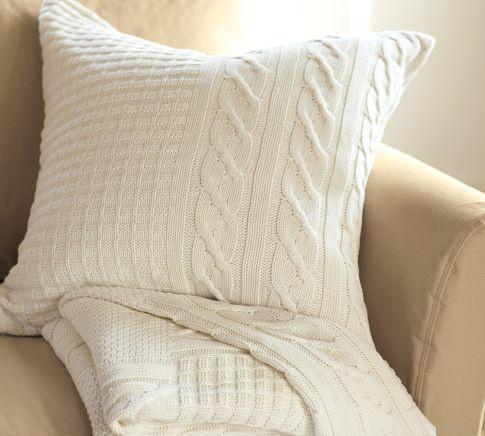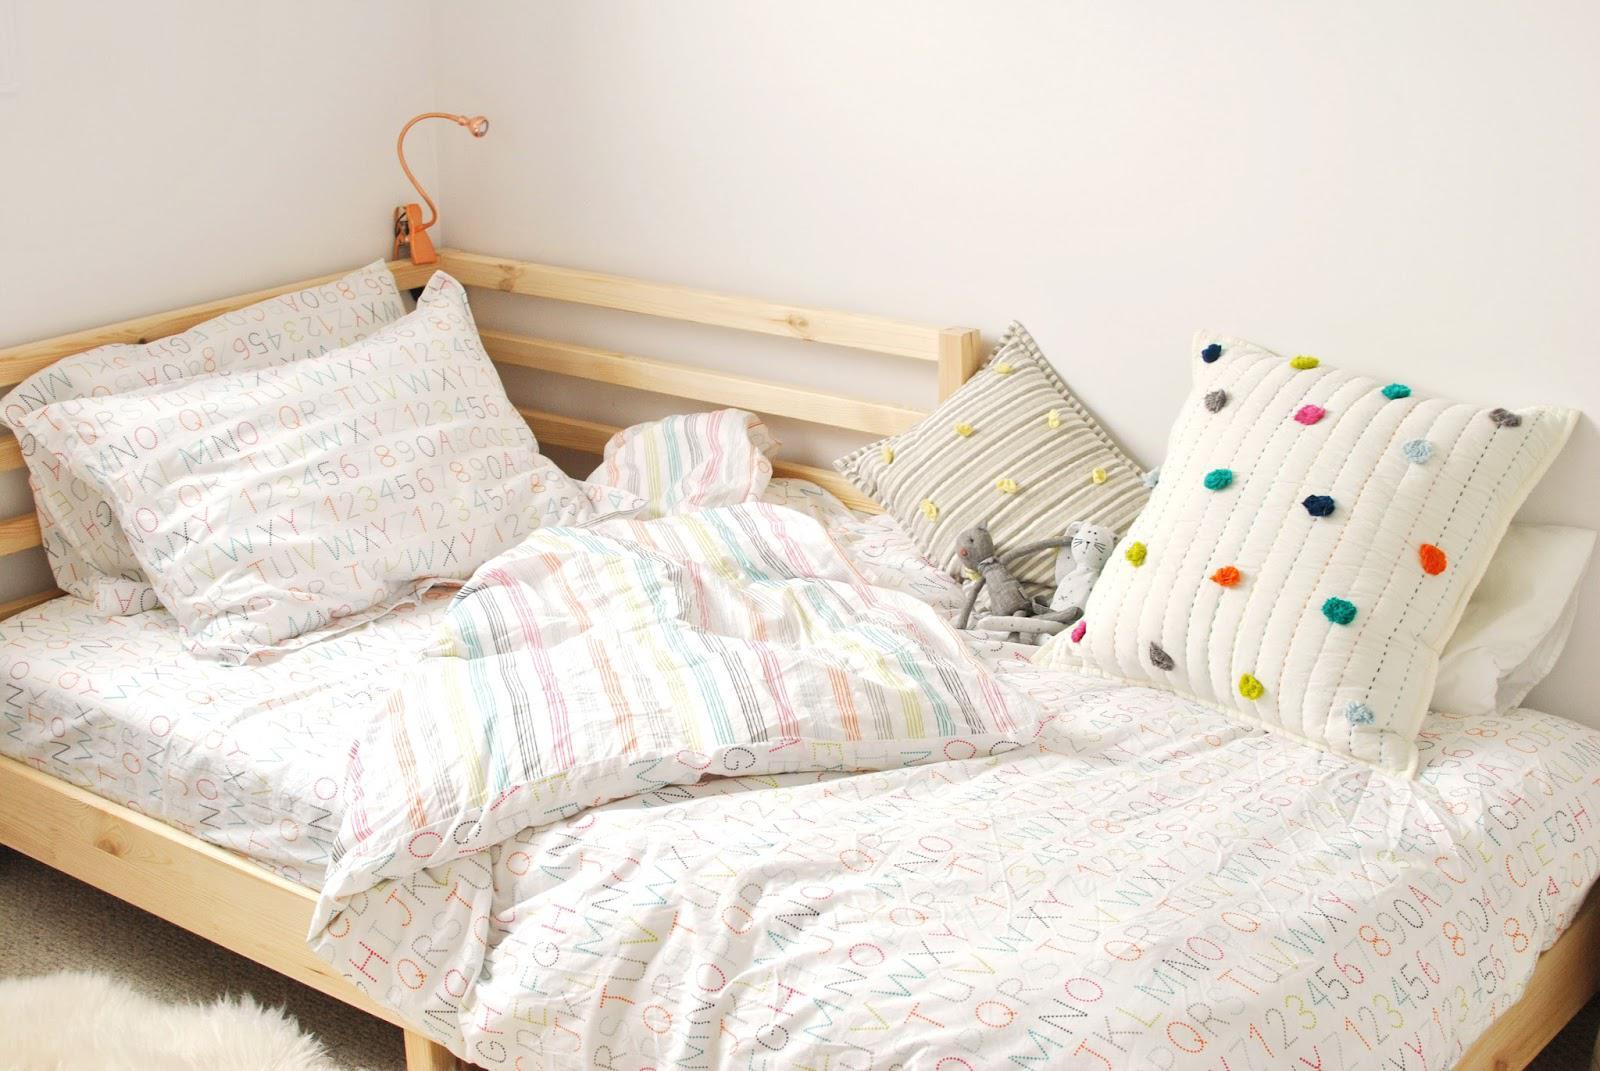The first image is the image on the left, the second image is the image on the right. Considering the images on both sides, is "In at least one image there is a single knitted pillow with a afghan on top of a sofa chair." valid? Answer yes or no. Yes. The first image is the image on the left, the second image is the image on the right. Analyze the images presented: Is the assertion "One image includes a square pale pillow with a horizontal row of at least three buttons, and the other image features multiple pillows on a white couch, including pillows with all-over picture prints." valid? Answer yes or no. No. 